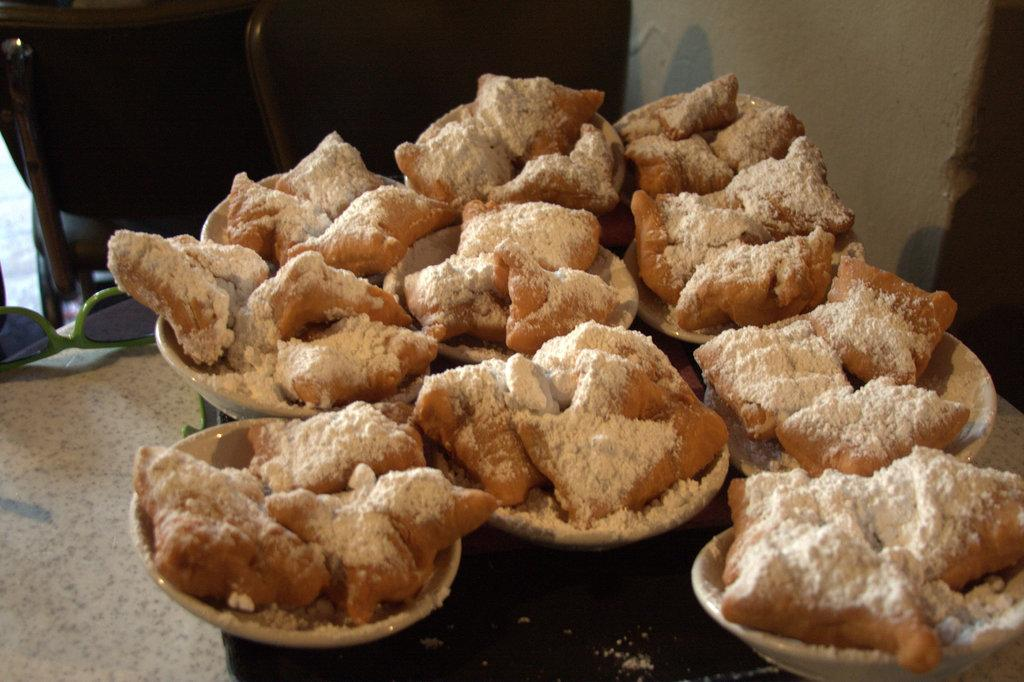What type of objects are present in the image? There are food items in the image. How are the food items arranged or contained? The food items are in bowls. What colors can be observed in the food items? The food items have brown and white colors. What is the color scheme of the background in the image? The background of the image is in white and black colors. What type of punishment is being administered to the sun in the image? There is no sun or punishment present in the image. 